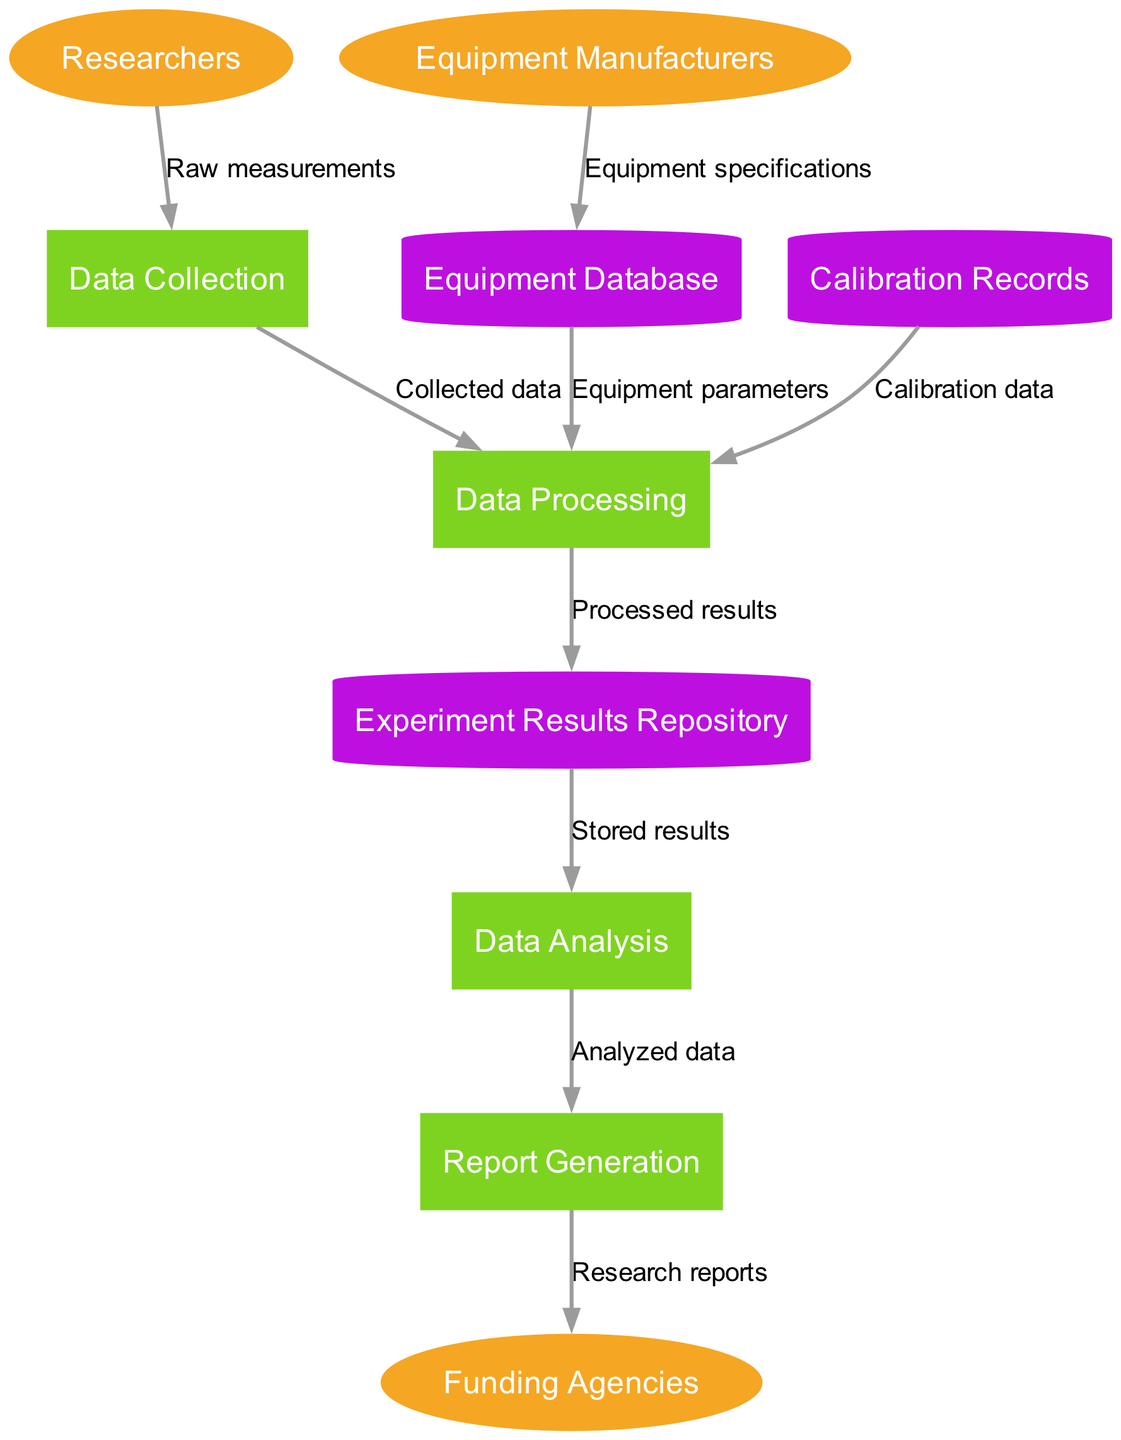What are the three external entities in the diagram? The external entities are listed in the diagram under the external entities section. They are Researchers, Equipment Manufacturers, and Funding Agencies.
Answer: Researchers, Equipment Manufacturers, Funding Agencies How many processes are illustrated in the diagram? The processes are the actions that flow data. By counting the listed processes in the diagram, we see there are four: Data Collection, Data Processing, Data Analysis, and Report Generation.
Answer: 4 What type of data flows from Data Collection to Data Processing? The label on the data flow from Data Collection to Data Processing indicates the type of data being transferred, which is “Collected data.”
Answer: Collected data Which data store receives processed results? The processed results flow from Data Processing to the data store. The label on the data flow specifies that the destination is the Experiment Results Repository.
Answer: Experiment Results Repository What is the relationship between Equipment Database and Data Processing? The Equipment Database provides Equipment parameters, which are sent to Data Processing. This shows a primary input-output relationship where Data Processing relies on Equipment parameters from the Equipment Database.
Answer: Equipment parameters Which node generates reports for Funding Agencies? The node responsible for generating reports directed to Funding Agencies is Report Generation, as shown by the data flow from Report Generation to Funding Agencies labeled "Research reports."
Answer: Report Generation How many total data stores are presented in the diagram? By reviewing the data stores listed, we find a total of three: Equipment Database, Experiment Results Repository, and Calibration Records.
Answer: 3 Which external entity provides specifications to the Equipment Database? The Equipment Manufacturers are the external entities supplying the Equipment specifications to the Equipment Database, as noted in the data flow description.
Answer: Equipment Manufacturers What type of data is sent from Calibration Records to Data Processing? The data coming from Calibration Records to Data Processing is labeled as “Calibration data,” specifying the type of information being transferred.
Answer: Calibration data 